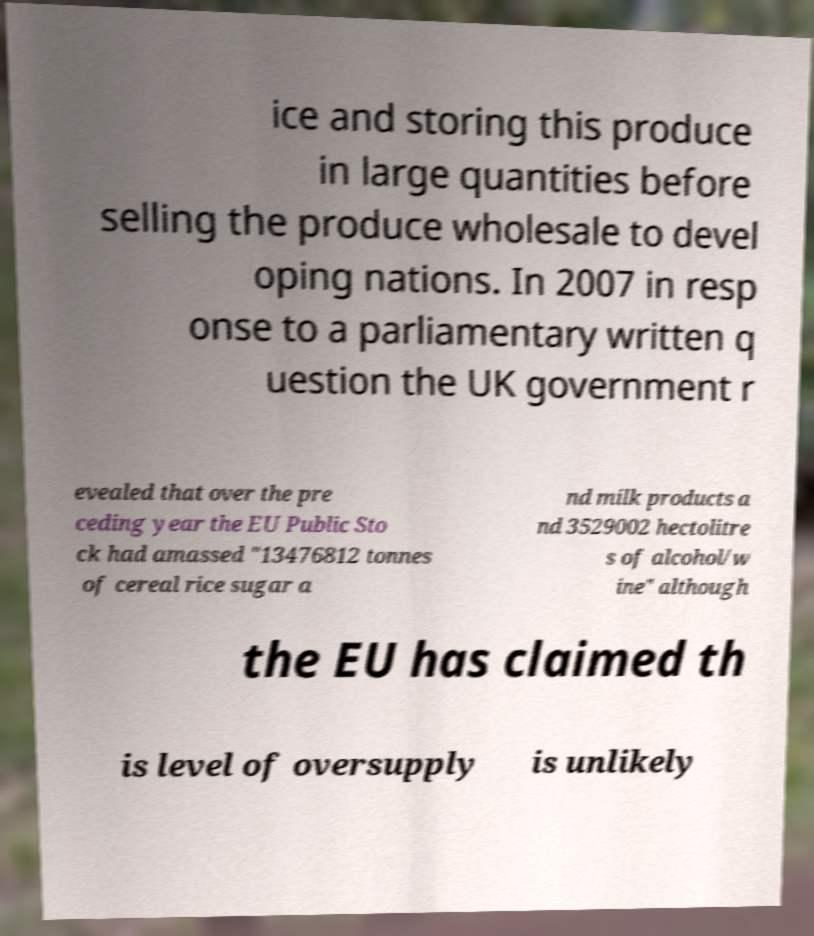Could you extract and type out the text from this image? ice and storing this produce in large quantities before selling the produce wholesale to devel oping nations. In 2007 in resp onse to a parliamentary written q uestion the UK government r evealed that over the pre ceding year the EU Public Sto ck had amassed "13476812 tonnes of cereal rice sugar a nd milk products a nd 3529002 hectolitre s of alcohol/w ine" although the EU has claimed th is level of oversupply is unlikely 